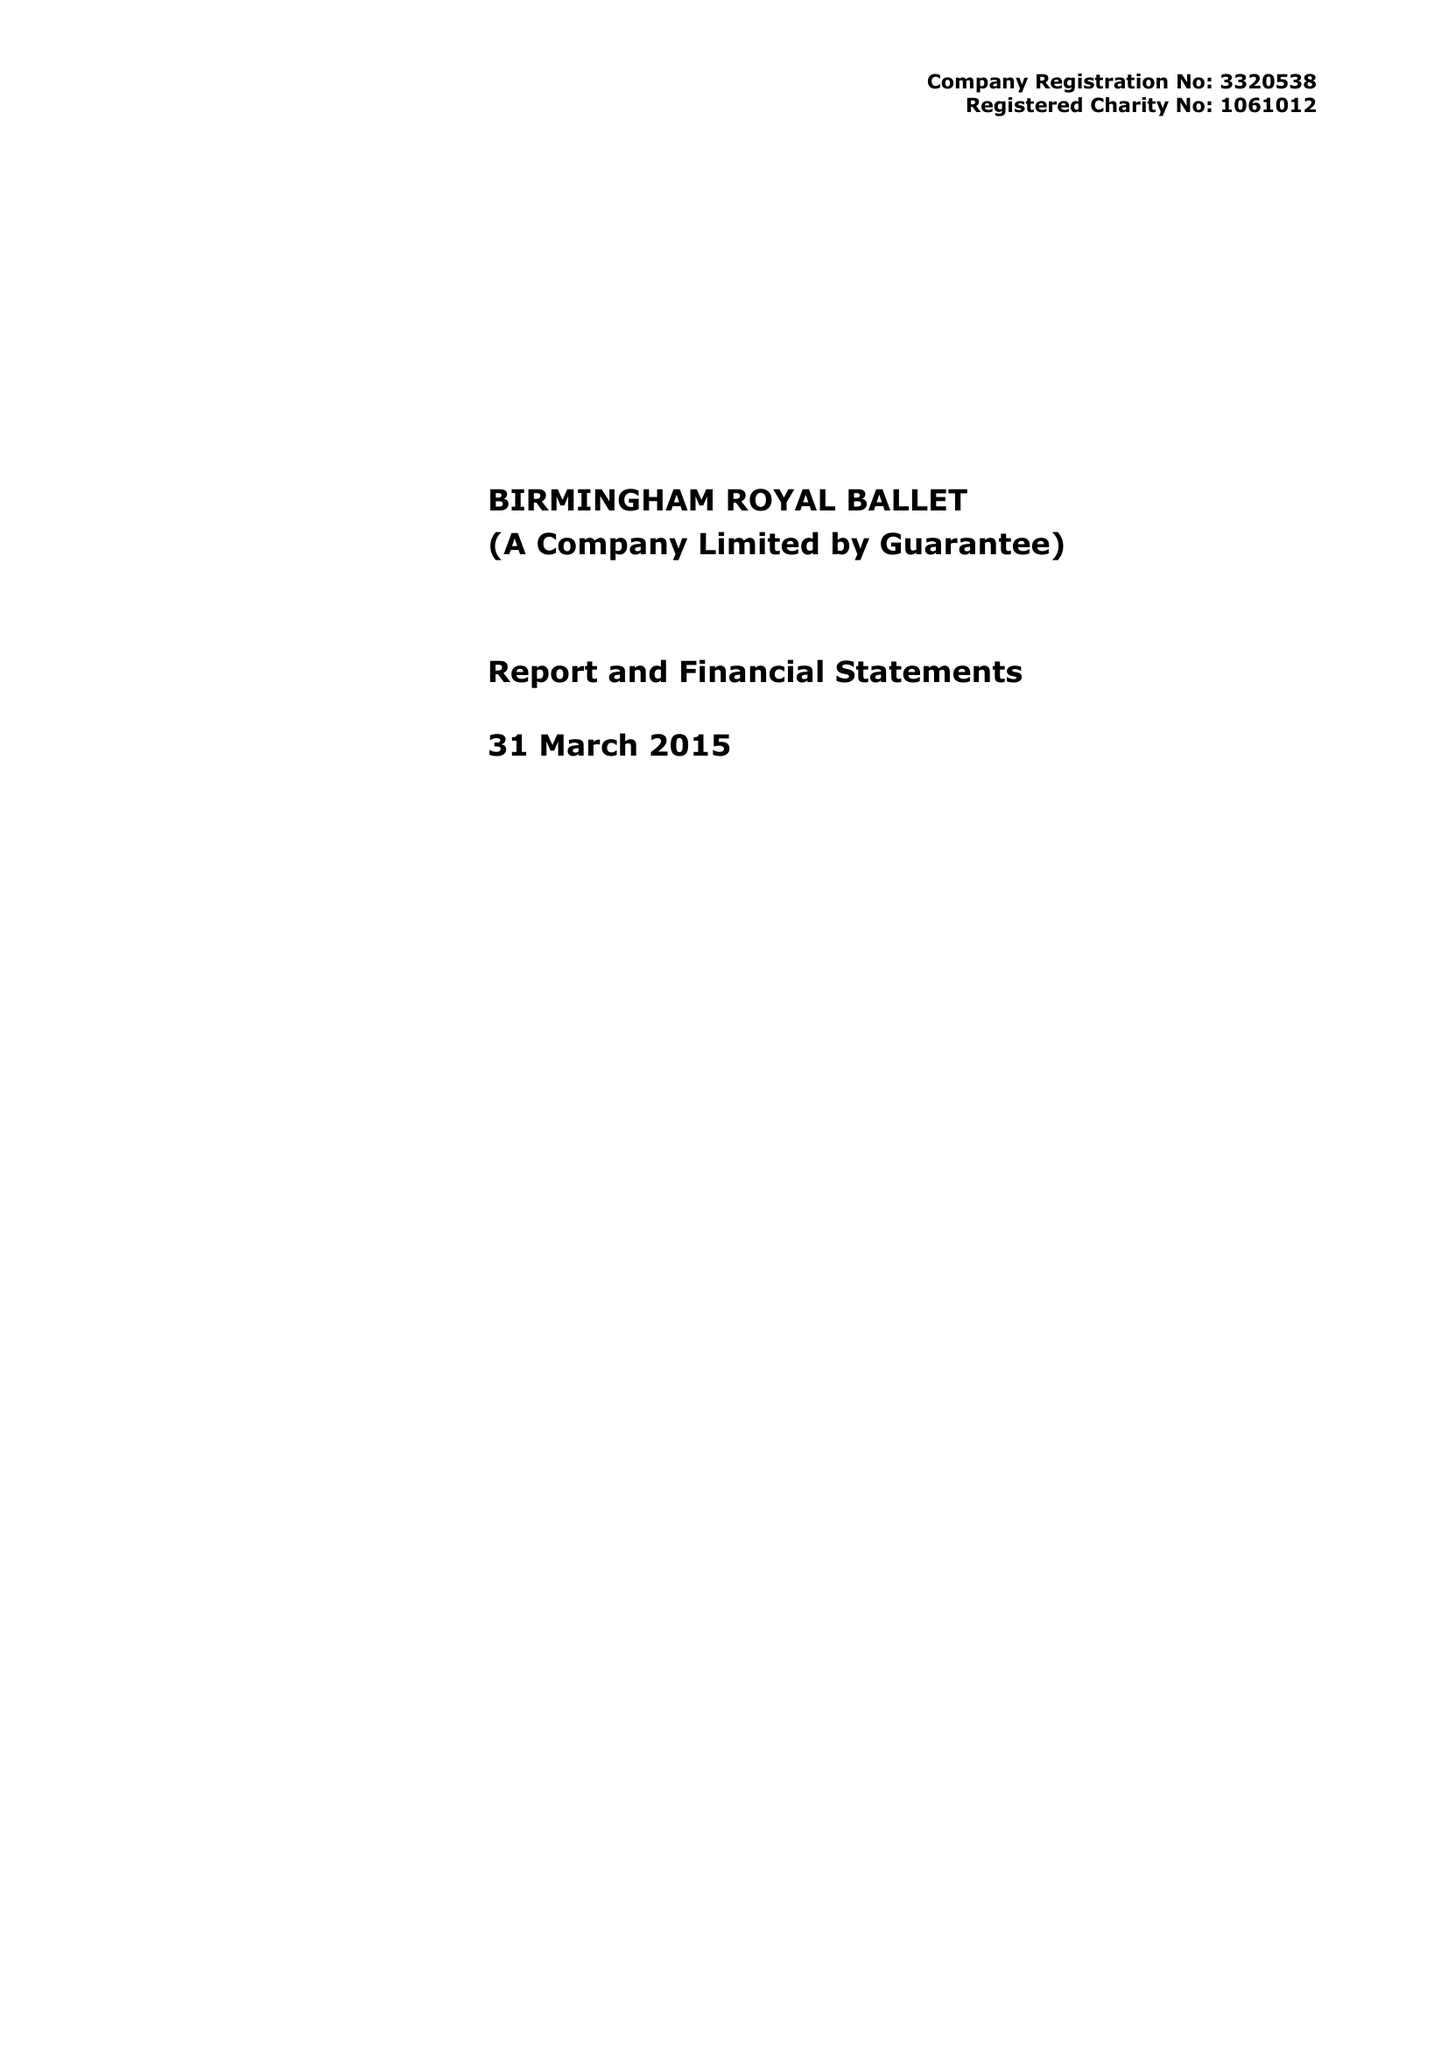What is the value for the address__street_line?
Answer the question using a single word or phrase. THORP STREET 